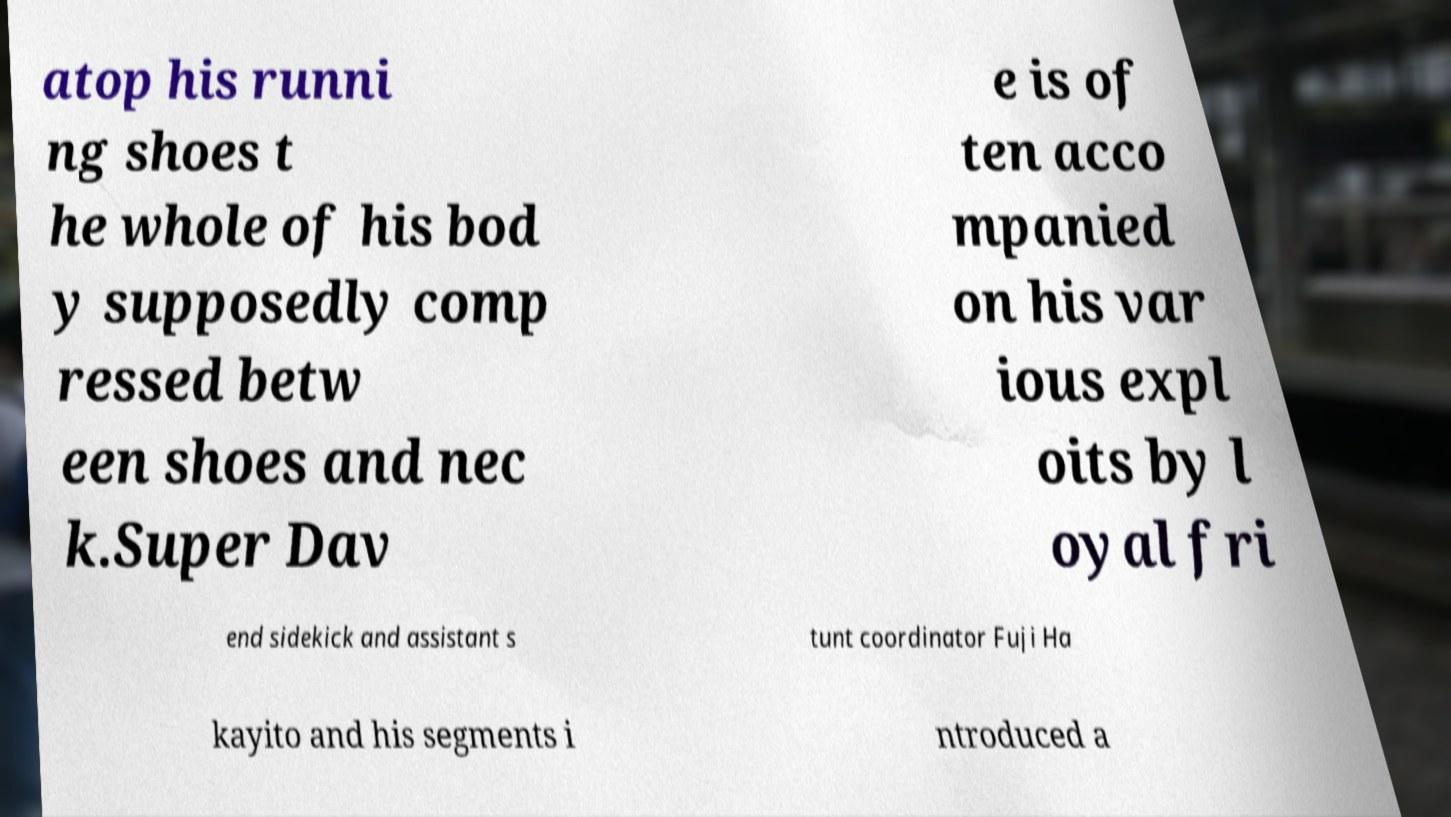What messages or text are displayed in this image? I need them in a readable, typed format. atop his runni ng shoes t he whole of his bod y supposedly comp ressed betw een shoes and nec k.Super Dav e is of ten acco mpanied on his var ious expl oits by l oyal fri end sidekick and assistant s tunt coordinator Fuji Ha kayito and his segments i ntroduced a 